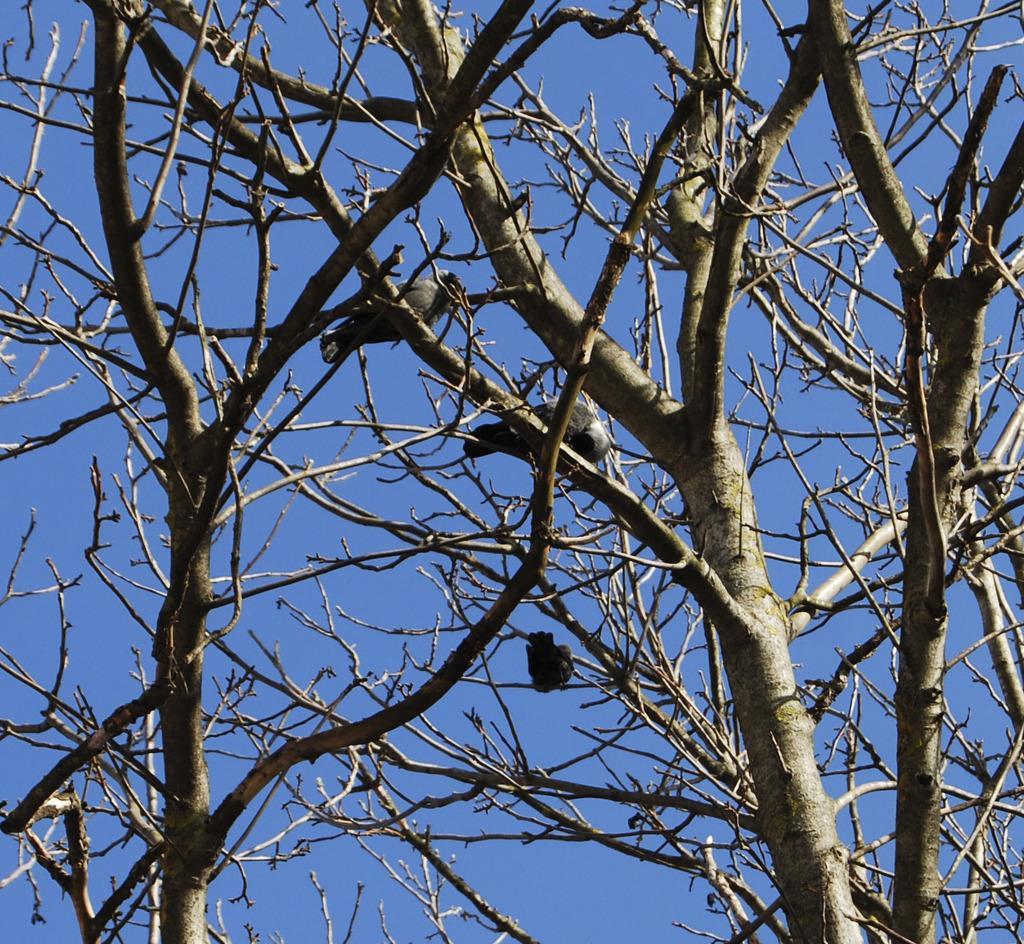Could you give a brief overview of what you see in this image? In this image I can see few birds are on the dry trees. The sky is in blue color. 